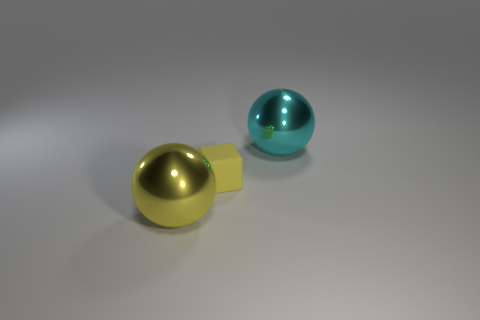How many other large shiny things are the same shape as the cyan metallic object?
Offer a very short reply. 1. There is another object that is the same size as the yellow shiny object; what color is it?
Provide a succinct answer. Cyan. Are there any yellow objects?
Offer a very short reply. Yes. The rubber object in front of the big cyan sphere has what shape?
Keep it short and to the point. Cube. How many metal objects are behind the yellow shiny thing and in front of the rubber block?
Your answer should be very brief. 0. Is there a ball that has the same material as the tiny cube?
Your response must be concise. No. What is the size of the metallic object that is the same color as the matte object?
Your response must be concise. Large. How many spheres are tiny purple metallic things or cyan metal things?
Give a very brief answer. 1. What is the size of the yellow cube?
Provide a short and direct response. Small. What number of yellow rubber things are on the right side of the yellow metal thing?
Offer a terse response. 1. 